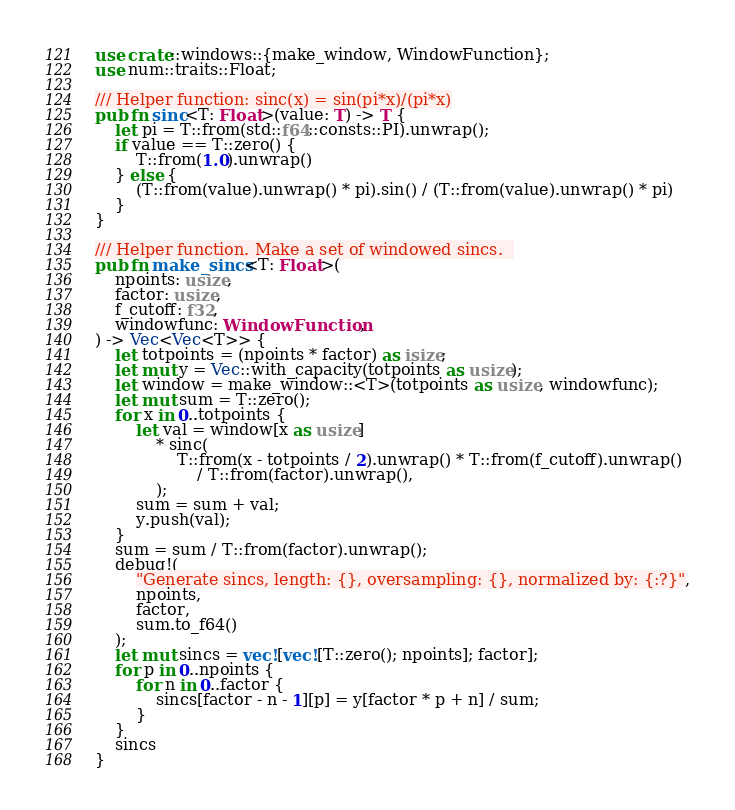<code> <loc_0><loc_0><loc_500><loc_500><_Rust_>use crate::windows::{make_window, WindowFunction};
use num::traits::Float;

/// Helper function: sinc(x) = sin(pi*x)/(pi*x)
pub fn sinc<T: Float>(value: T) -> T {
    let pi = T::from(std::f64::consts::PI).unwrap();
    if value == T::zero() {
        T::from(1.0).unwrap()
    } else {
        (T::from(value).unwrap() * pi).sin() / (T::from(value).unwrap() * pi)
    }
}

/// Helper function. Make a set of windowed sincs.  
pub fn make_sincs<T: Float>(
    npoints: usize,
    factor: usize,
    f_cutoff: f32,
    windowfunc: WindowFunction,
) -> Vec<Vec<T>> {
    let totpoints = (npoints * factor) as isize;
    let mut y = Vec::with_capacity(totpoints as usize);
    let window = make_window::<T>(totpoints as usize, windowfunc);
    let mut sum = T::zero();
    for x in 0..totpoints {
        let val = window[x as usize]
            * sinc(
                T::from(x - totpoints / 2).unwrap() * T::from(f_cutoff).unwrap()
                    / T::from(factor).unwrap(),
            );
        sum = sum + val;
        y.push(val);
    }
    sum = sum / T::from(factor).unwrap();
    debug!(
        "Generate sincs, length: {}, oversampling: {}, normalized by: {:?}",
        npoints,
        factor,
        sum.to_f64()
    );
    let mut sincs = vec![vec![T::zero(); npoints]; factor];
    for p in 0..npoints {
        for n in 0..factor {
            sincs[factor - n - 1][p] = y[factor * p + n] / sum;
        }
    }
    sincs
}
</code> 